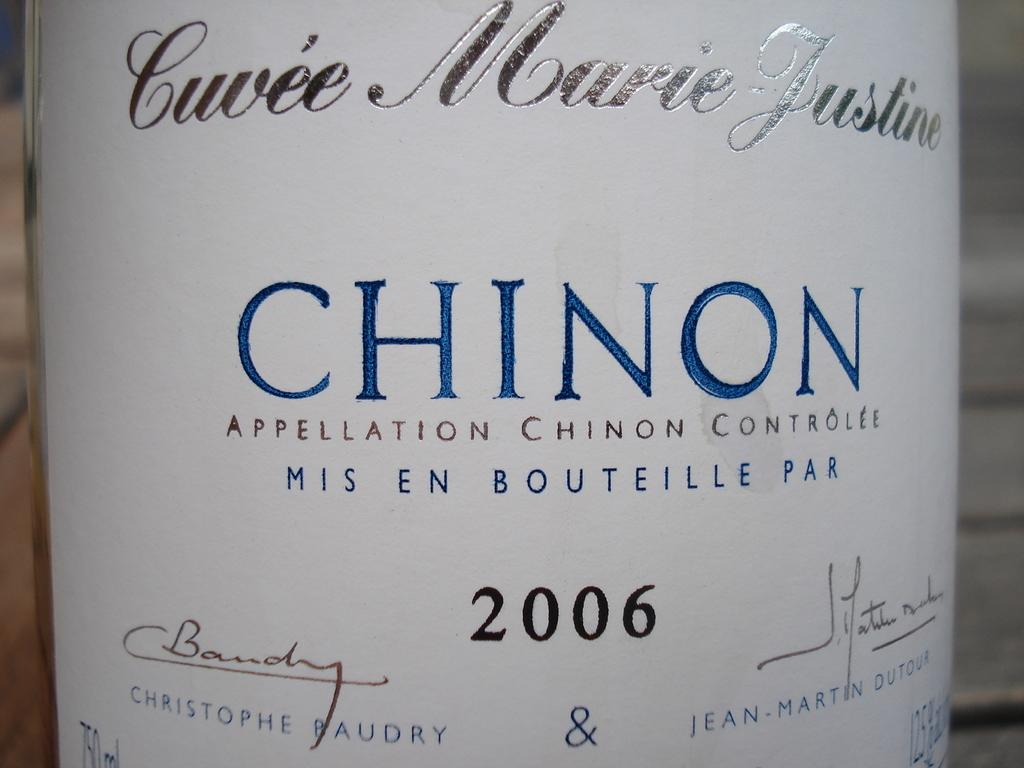What is the main object in the center of the image? There is a wine bottle in the center of the image. Can you describe the wine bottle in more detail? Unfortunately, the facts provided do not give any additional details about the wine bottle. How many balls are visible in the scene in the image? There are no balls visible in the image; it only features a wine bottle. What nation is depicted in the image? The image does not depict any nation; it only features a wine bottle. 